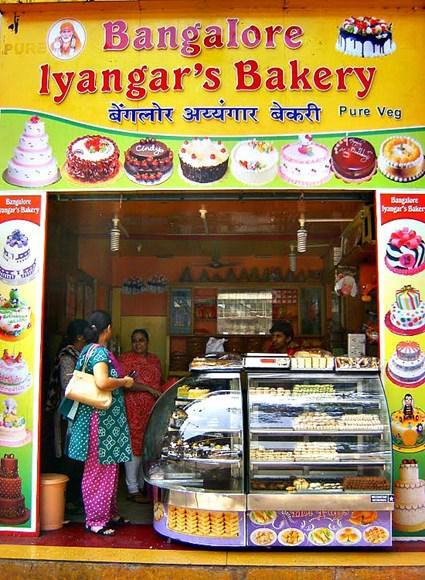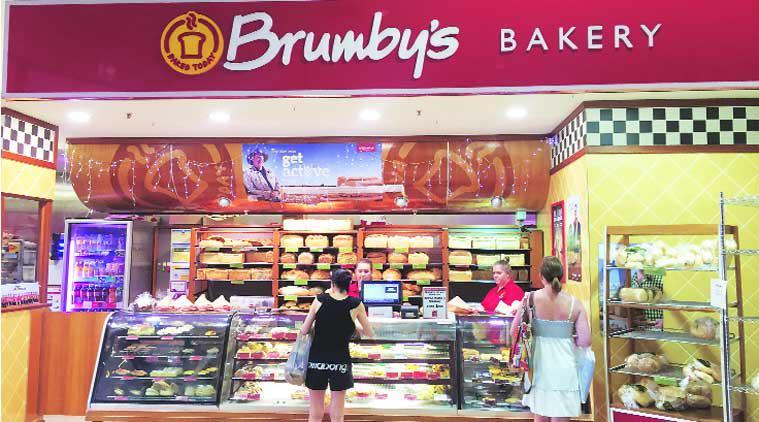The first image is the image on the left, the second image is the image on the right. Considering the images on both sides, is "The bakery's name is visible in at least one image." valid? Answer yes or no. Yes. The first image is the image on the left, the second image is the image on the right. Given the left and right images, does the statement "In at least one image there is no less than 4 men standing behind the baked goods counter." hold true? Answer yes or no. No. 